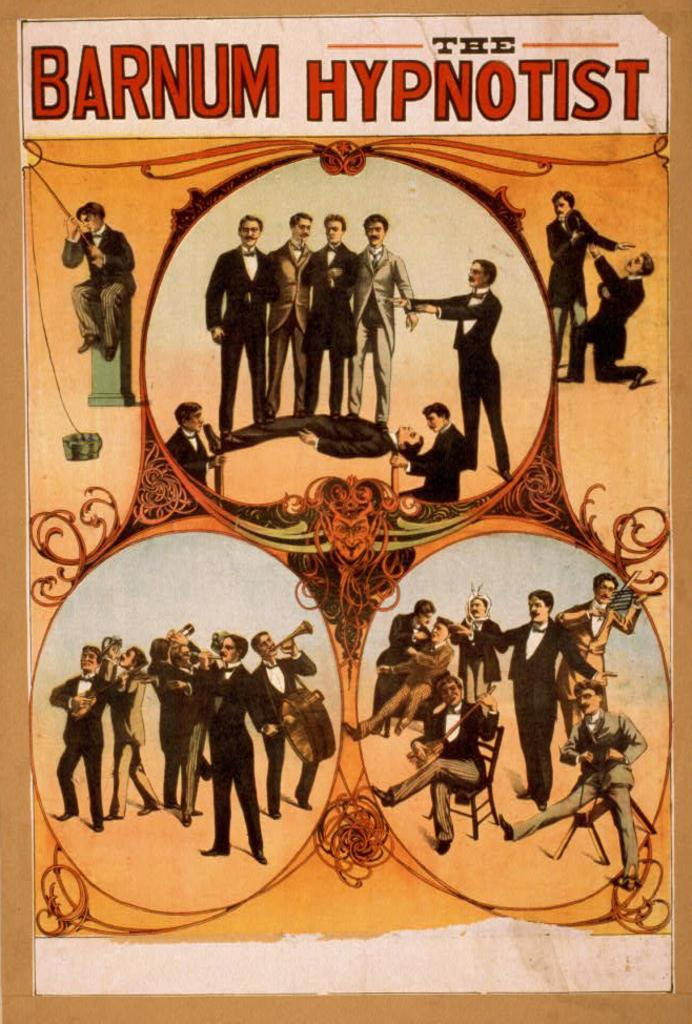<image>
Give a short and clear explanation of the subsequent image. An old poster that shows different images of Barnum the Hypnotist. 